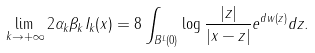Convert formula to latex. <formula><loc_0><loc_0><loc_500><loc_500>\lim _ { k \rightarrow + \infty } 2 \alpha _ { k } \beta _ { k } I _ { k } ( x ) = 8 \int _ { B ^ { L } ( 0 ) } \log \frac { | z | } { | x - z | } e ^ { d w ( z ) } d z .</formula> 